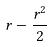Convert formula to latex. <formula><loc_0><loc_0><loc_500><loc_500>r - \frac { r ^ { 2 } } { 2 }</formula> 